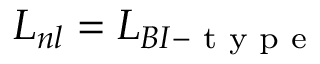<formula> <loc_0><loc_0><loc_500><loc_500>L _ { n l } = L _ { B I - t y p e }</formula> 